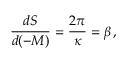Convert formula to latex. <formula><loc_0><loc_0><loc_500><loc_500>\frac { d S } { d ( - M ) } = \frac { 2 \pi } { \kappa } = \beta \, ,</formula> 